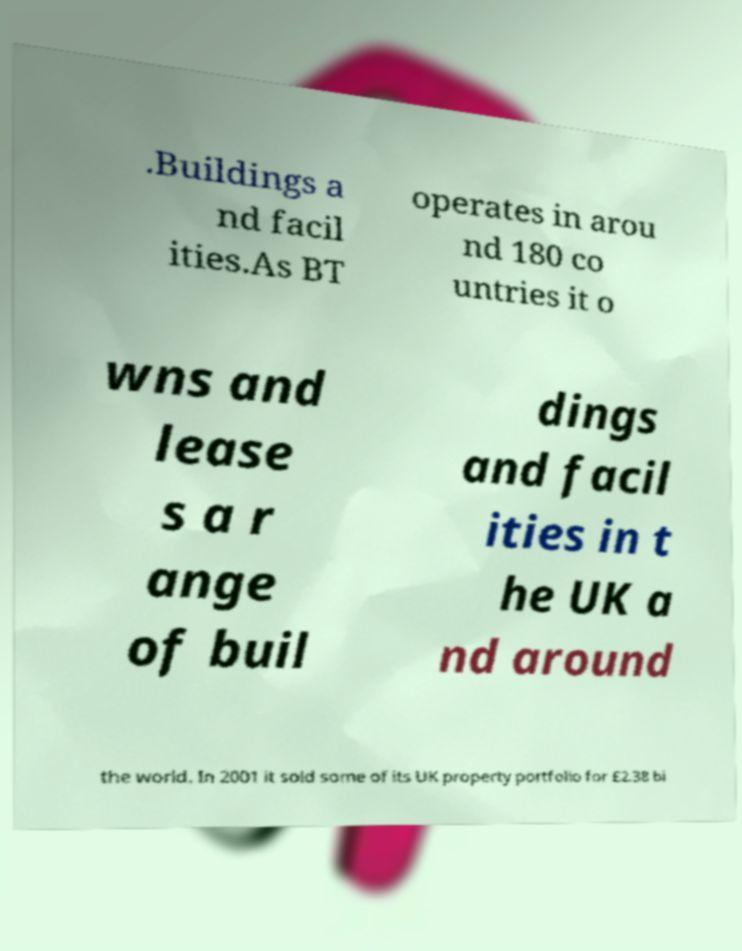Can you read and provide the text displayed in the image?This photo seems to have some interesting text. Can you extract and type it out for me? .Buildings a nd facil ities.As BT operates in arou nd 180 co untries it o wns and lease s a r ange of buil dings and facil ities in t he UK a nd around the world. In 2001 it sold some of its UK property portfolio for £2.38 bi 